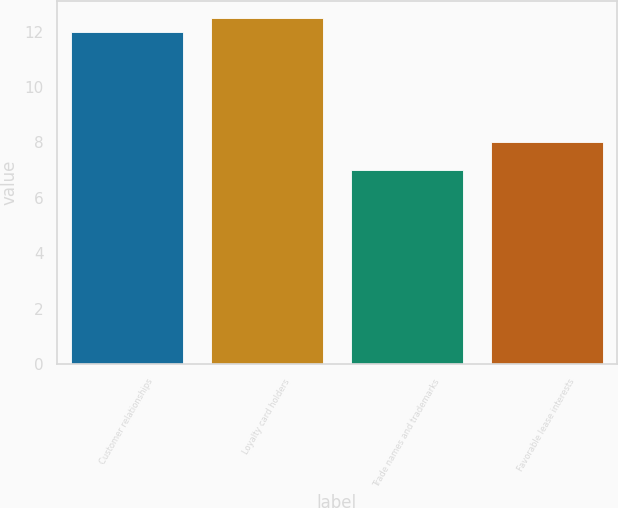Convert chart. <chart><loc_0><loc_0><loc_500><loc_500><bar_chart><fcel>Customer relationships<fcel>Loyalty card holders<fcel>Trade names and trademarks<fcel>Favorable lease interests<nl><fcel>12<fcel>12.5<fcel>7<fcel>8<nl></chart> 